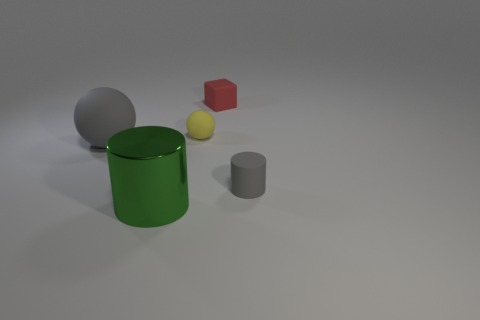There is a sphere that is behind the gray object that is to the left of the small gray matte object; what is its color?
Provide a succinct answer. Yellow. What number of metallic things are either gray cylinders or large blue cubes?
Your response must be concise. 0. Do the green thing and the small gray object have the same material?
Your answer should be compact. No. What is the sphere that is to the right of the gray thing that is on the left side of the tiny matte cube made of?
Your answer should be very brief. Rubber. What number of tiny objects are either purple things or gray rubber cylinders?
Ensure brevity in your answer.  1. The red rubber thing has what size?
Give a very brief answer. Small. Are there more matte cubes that are behind the red rubber cube than yellow objects?
Offer a very short reply. No. Are there an equal number of tiny yellow rubber objects that are left of the yellow rubber ball and green cylinders that are left of the big gray sphere?
Offer a very short reply. Yes. What color is the rubber thing that is in front of the tiny red matte block and behind the big rubber sphere?
Provide a short and direct response. Yellow. Are there any other things that have the same size as the matte block?
Offer a very short reply. Yes. 